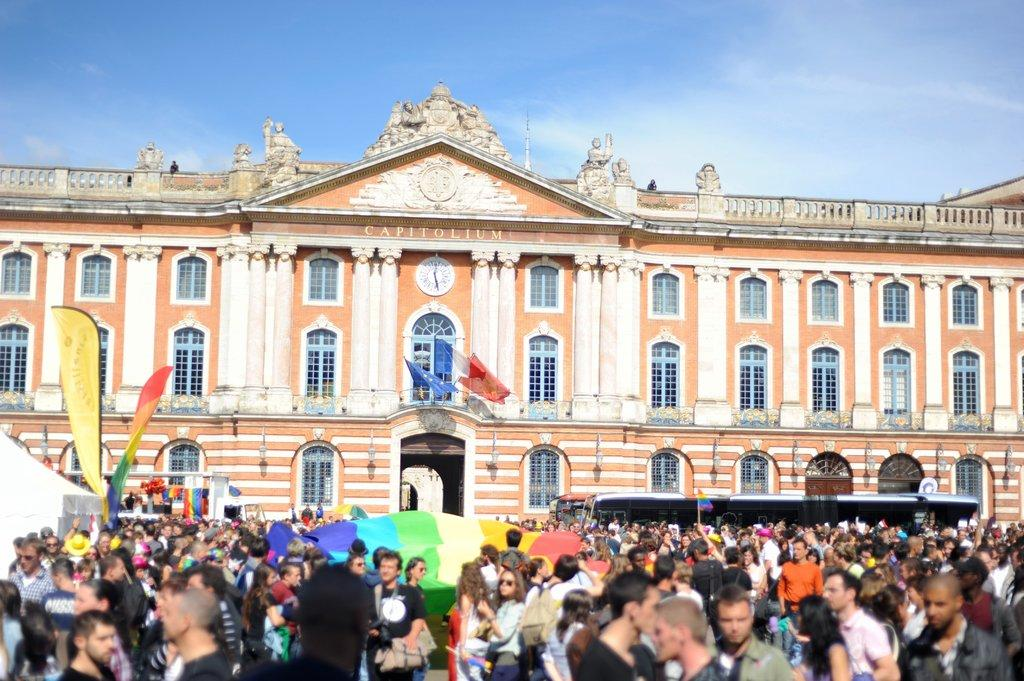How many people are in the group that is visible in the image? There is a group of people standing in the image, but the exact number cannot be determined from the provided facts. What type of structures can be seen in the image? There are buildings in the image. What additional objects are present in the image? There are flags and a clock visible in the image. What can be seen in the sky in the image? The sky is visible in the image, but no specific details about the sky are provided. What type of leather is used to make the glass in the image? There is no leather or glass present in the image; it features a group of people, buildings, flags, and a clock. 